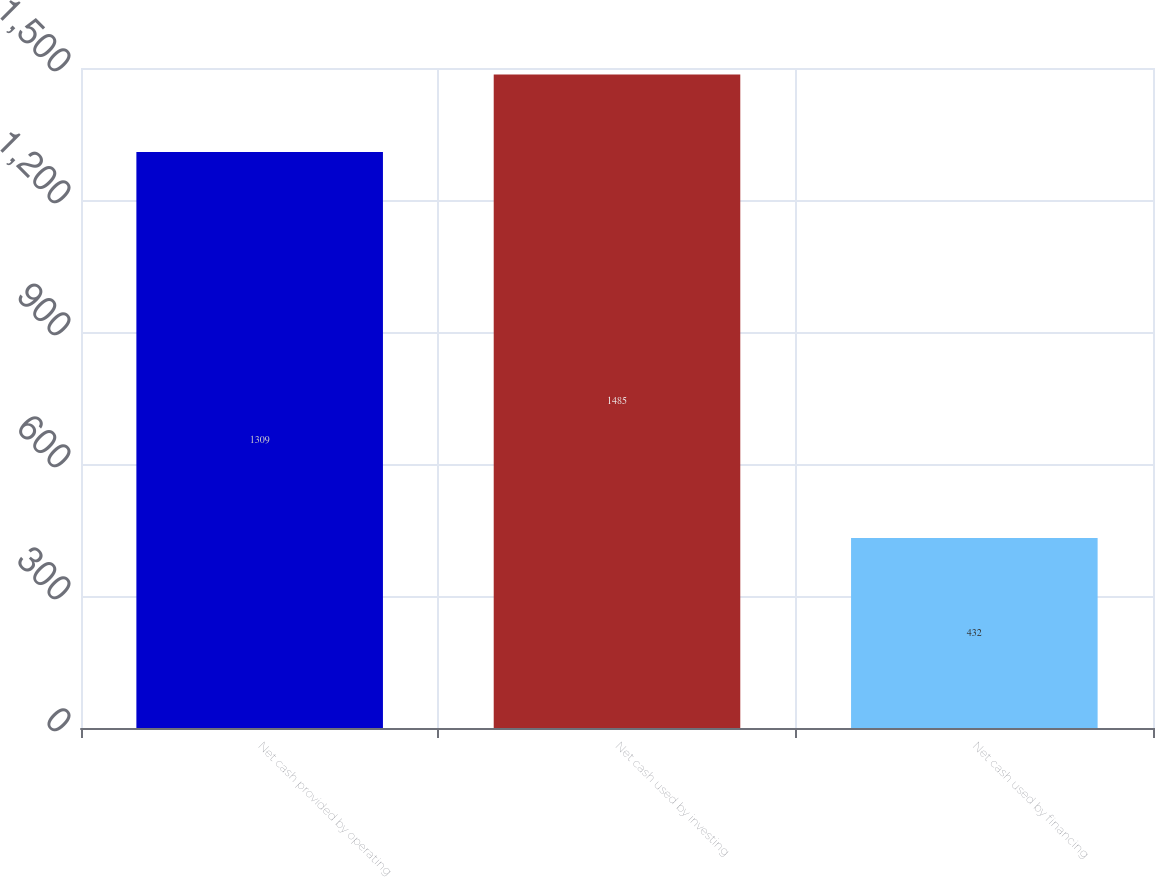<chart> <loc_0><loc_0><loc_500><loc_500><bar_chart><fcel>Net cash provided by operating<fcel>Net cash used by investing<fcel>Net cash used by financing<nl><fcel>1309<fcel>1485<fcel>432<nl></chart> 